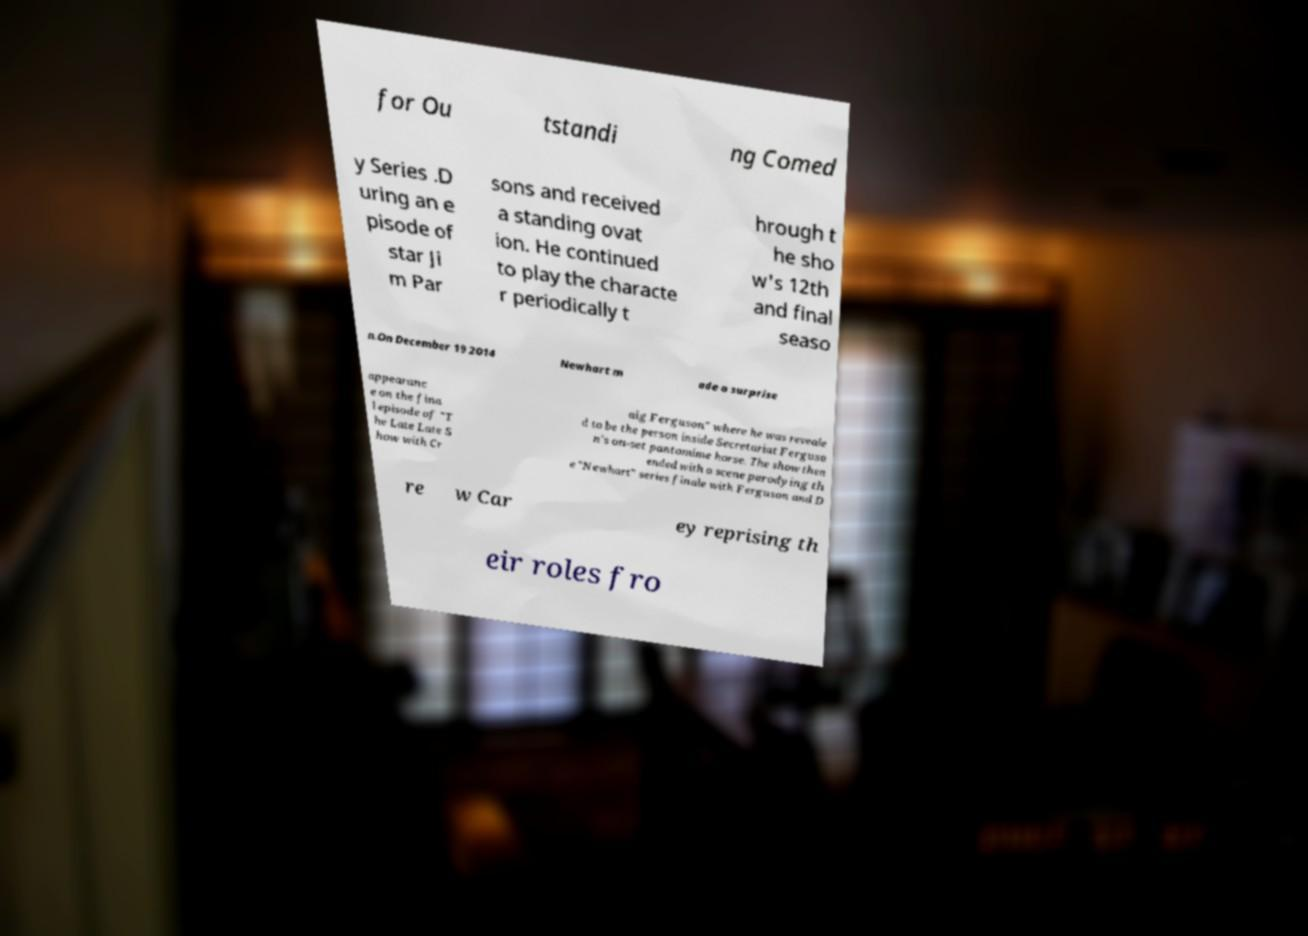Can you read and provide the text displayed in the image?This photo seems to have some interesting text. Can you extract and type it out for me? for Ou tstandi ng Comed y Series .D uring an e pisode of star Ji m Par sons and received a standing ovat ion. He continued to play the characte r periodically t hrough t he sho w's 12th and final seaso n.On December 19 2014 Newhart m ade a surprise appearanc e on the fina l episode of "T he Late Late S how with Cr aig Ferguson" where he was reveale d to be the person inside Secretariat Ferguso n's on-set pantomime horse. The show then ended with a scene parodying th e "Newhart" series finale with Ferguson and D re w Car ey reprising th eir roles fro 